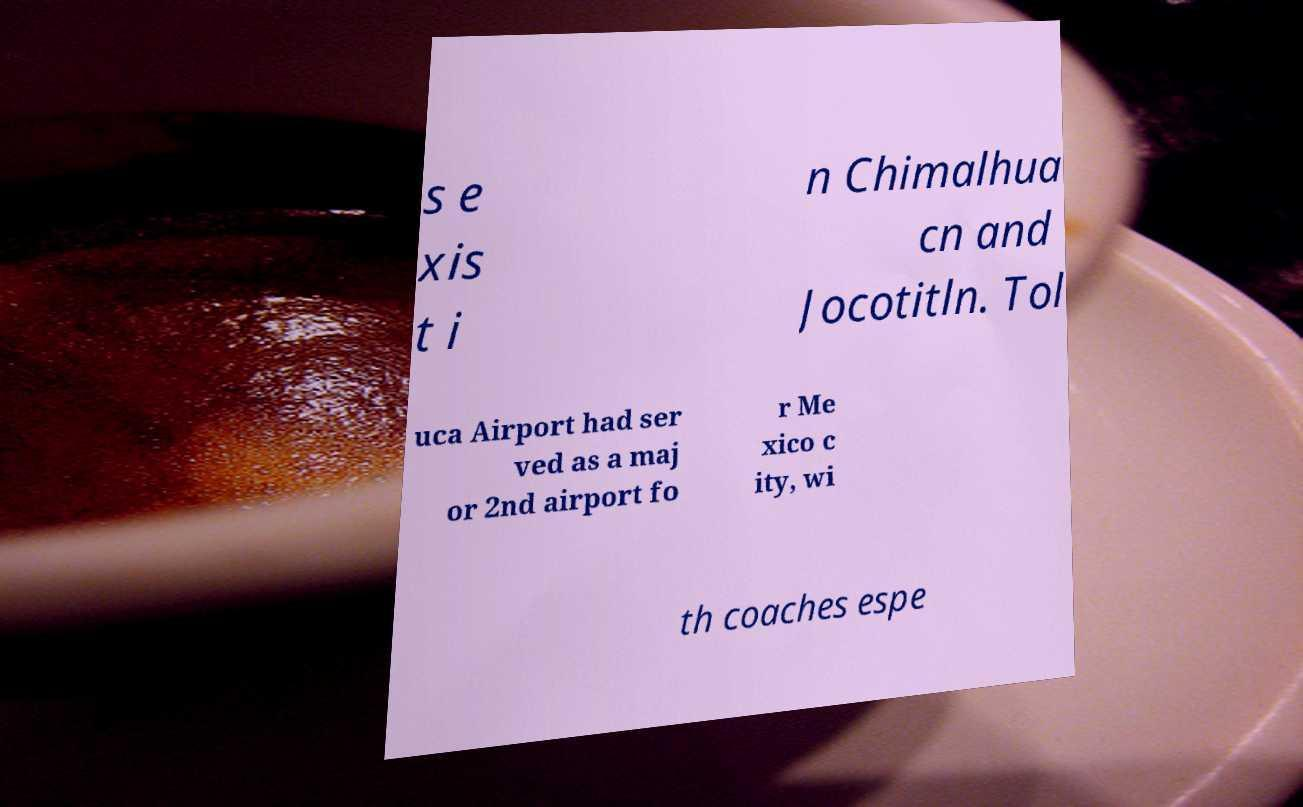Can you accurately transcribe the text from the provided image for me? s e xis t i n Chimalhua cn and Jocotitln. Tol uca Airport had ser ved as a maj or 2nd airport fo r Me xico c ity, wi th coaches espe 